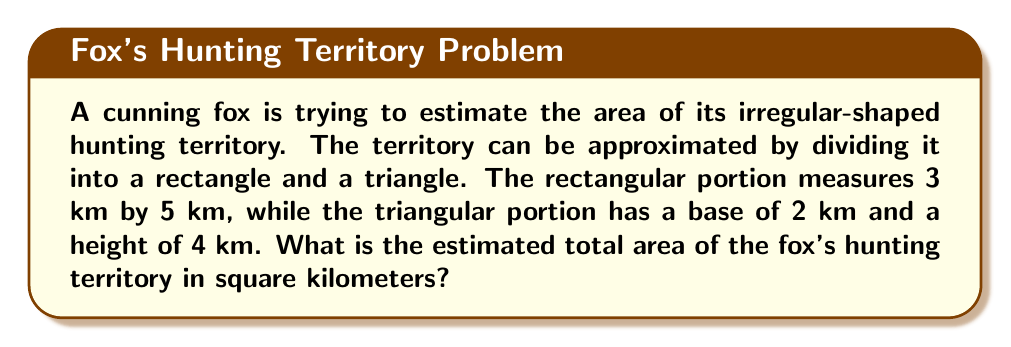Can you answer this question? To solve this problem, we need to calculate the areas of the rectangle and triangle separately, then add them together. Let's break it down step-by-step:

1. Calculate the area of the rectangle:
   $$A_{rectangle} = length \times width$$
   $$A_{rectangle} = 3 \text{ km} \times 5 \text{ km} = 15 \text{ km}^2$$

2. Calculate the area of the triangle:
   $$A_{triangle} = \frac{1}{2} \times base \times height$$
   $$A_{triangle} = \frac{1}{2} \times 2 \text{ km} \times 4 \text{ km} = 4 \text{ km}^2$$

3. Sum up the areas to get the total estimated hunting territory:
   $$A_{total} = A_{rectangle} + A_{triangle}$$
   $$A_{total} = 15 \text{ km}^2 + 4 \text{ km}^2 = 19 \text{ km}^2$$

Therefore, the estimated total area of the fox's hunting territory is 19 square kilometers.
Answer: 19 km² 